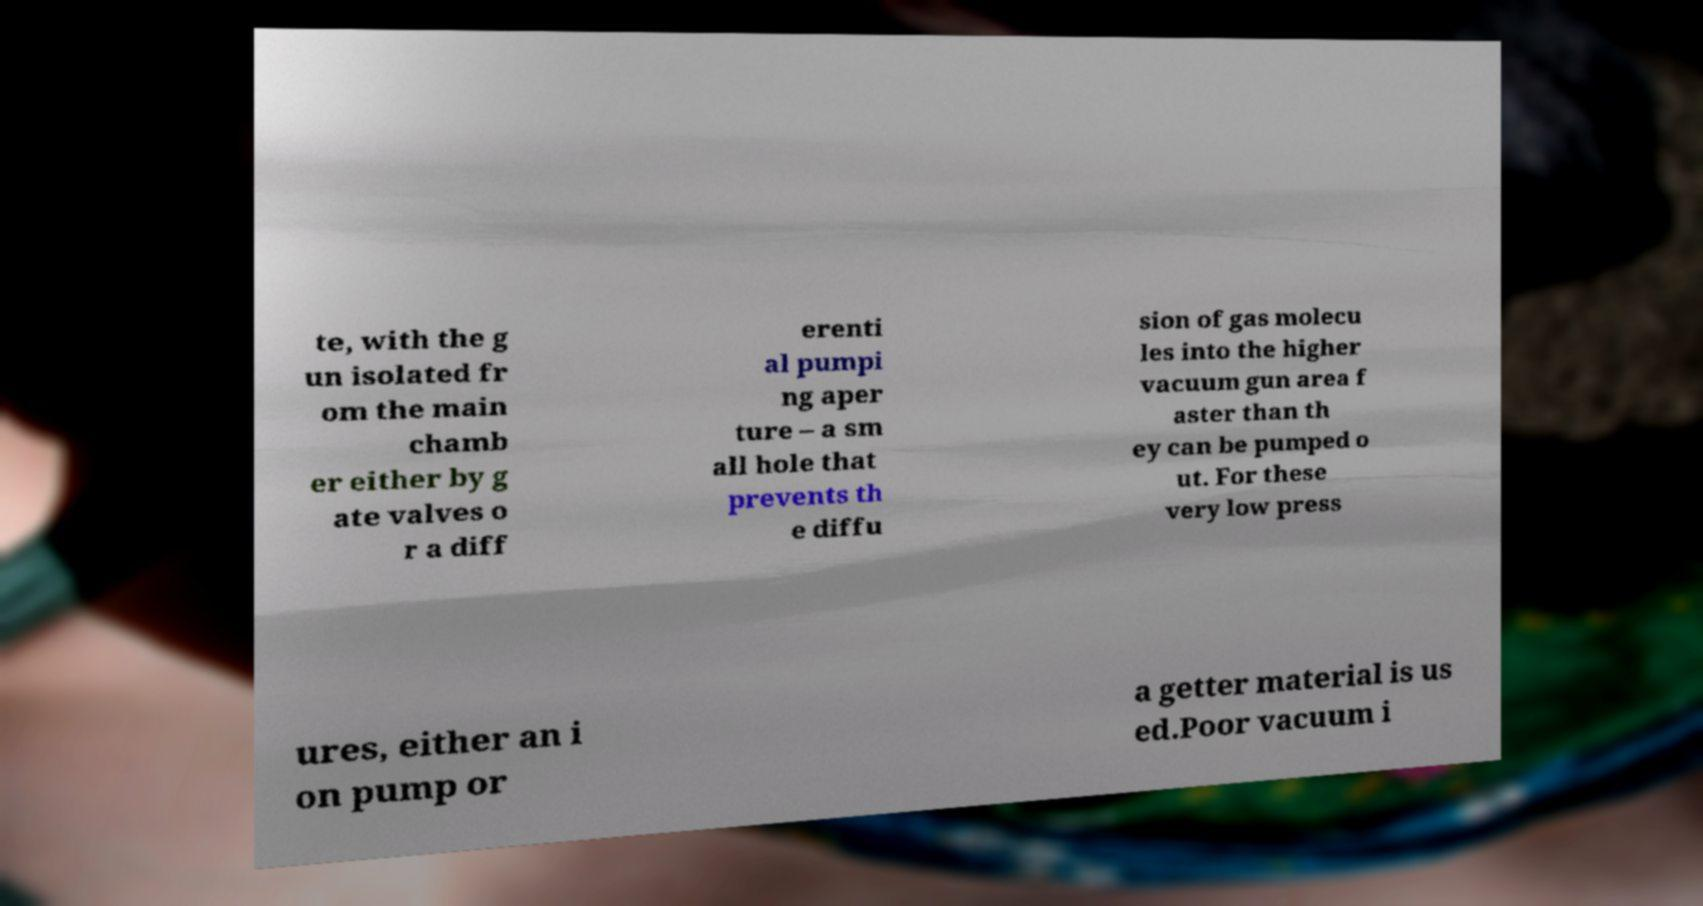Please identify and transcribe the text found in this image. te, with the g un isolated fr om the main chamb er either by g ate valves o r a diff erenti al pumpi ng aper ture – a sm all hole that prevents th e diffu sion of gas molecu les into the higher vacuum gun area f aster than th ey can be pumped o ut. For these very low press ures, either an i on pump or a getter material is us ed.Poor vacuum i 